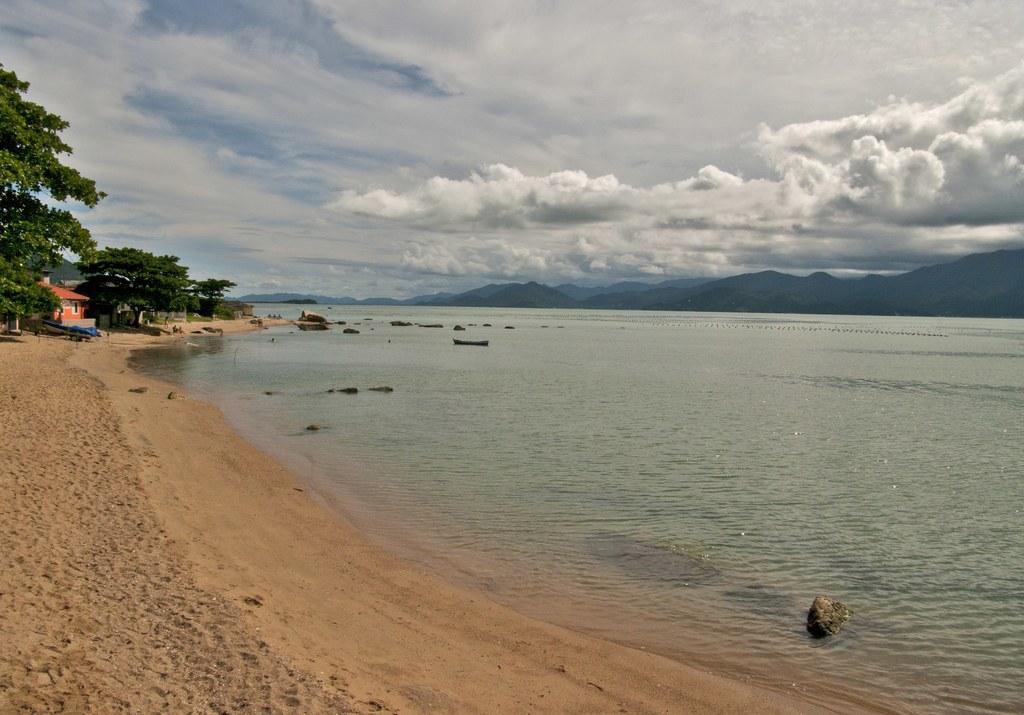Please provide a concise description of this image. At the bottom of the picture, we see the sand. In the middle, we see the water and this water might be in the sea. On the left side, we see the trees and a building in orange color. There are hills in the background. At the top, we see the sky and the clouds. 